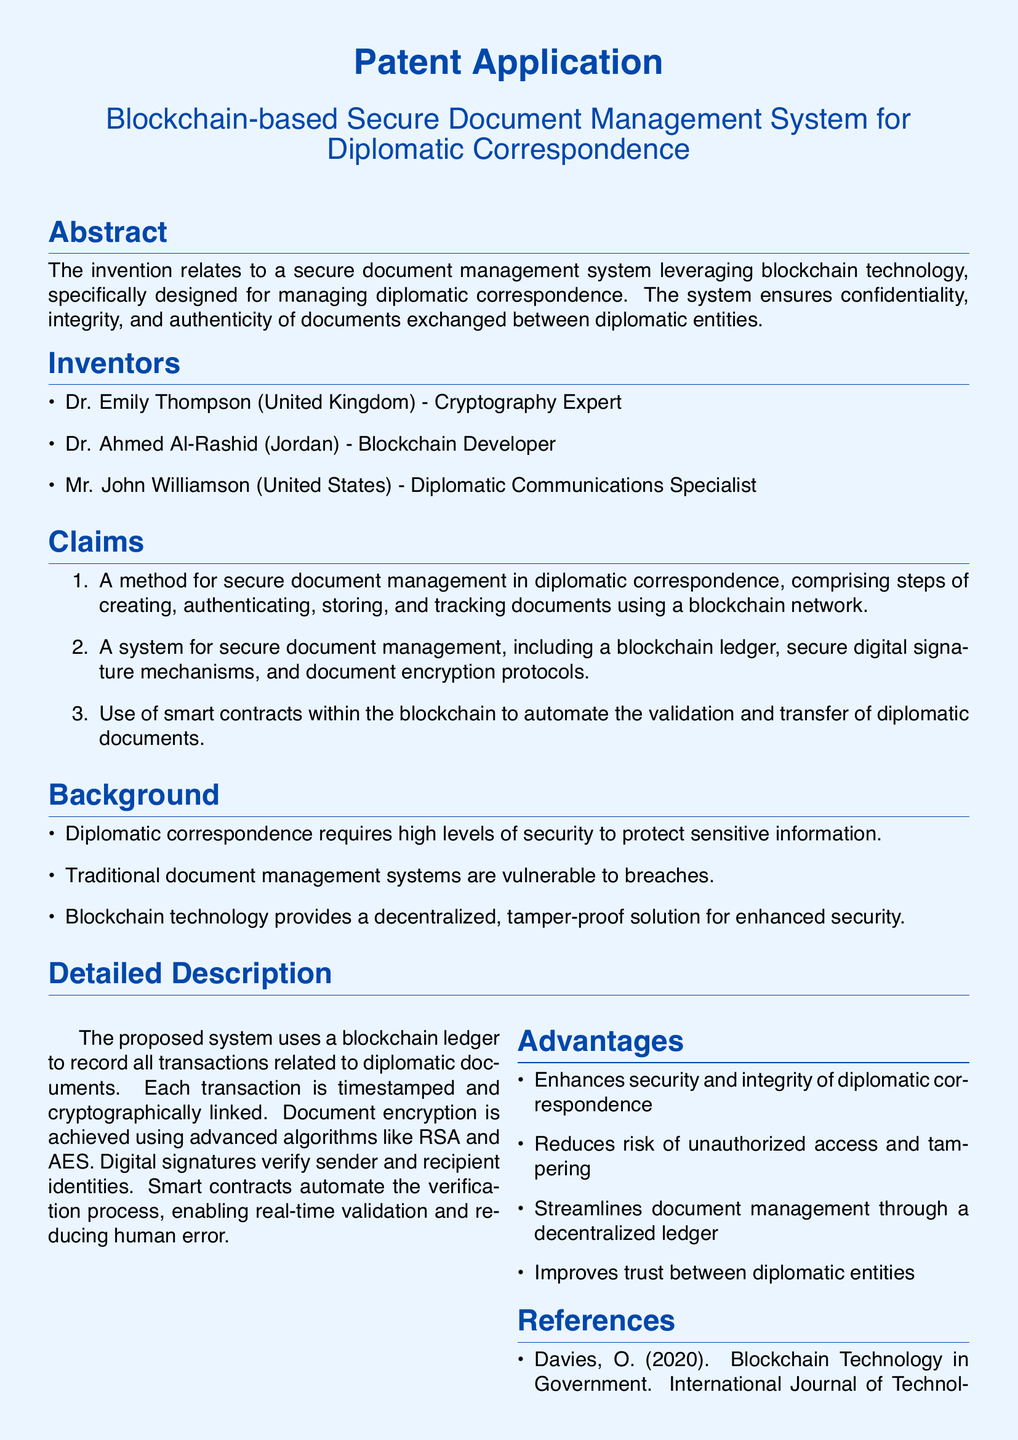What is the title of the patent application? The title is listed at the top of the document as the main focus, specifically identifying the subject.
Answer: Blockchain-based Secure Document Management System for Diplomatic Correspondence Who is a cryptography expert among the inventors? The inventors' section identifies individuals along with their expertise, thus allowing us to directly associate expertise with names.
Answer: Dr. Emily Thompson What is the first claim of the patent? The claims section outlines the inventions, and the numbering allows us to pinpoint the first claim easily.
Answer: A method for secure document management in diplomatic correspondence Which two encryption algorithms are mentioned in the detailed description? The detailed description highlights the technical aspects, naming specific algorithms used for document encryption.
Answer: RSA and AES What is one of the advantages of the proposed system? The advantages section lists benefits clearly, providing straightforward answers to their effectiveness.
Answer: Enhances security and integrity of diplomatic correspondence How many inventors are listed in the document? The inventors section includes a list, and counting them provides the answer directly.
Answer: Three What does the system use to automate the approval process? The document describes specific functionality of the system, allowing us to identify what is used for automation.
Answer: Smart contracts What journal is referenced regarding cryptographic security? The references section cites publications, providing us with specific titles of resources related to the patent's context.
Answer: Journal of International Security Studies 